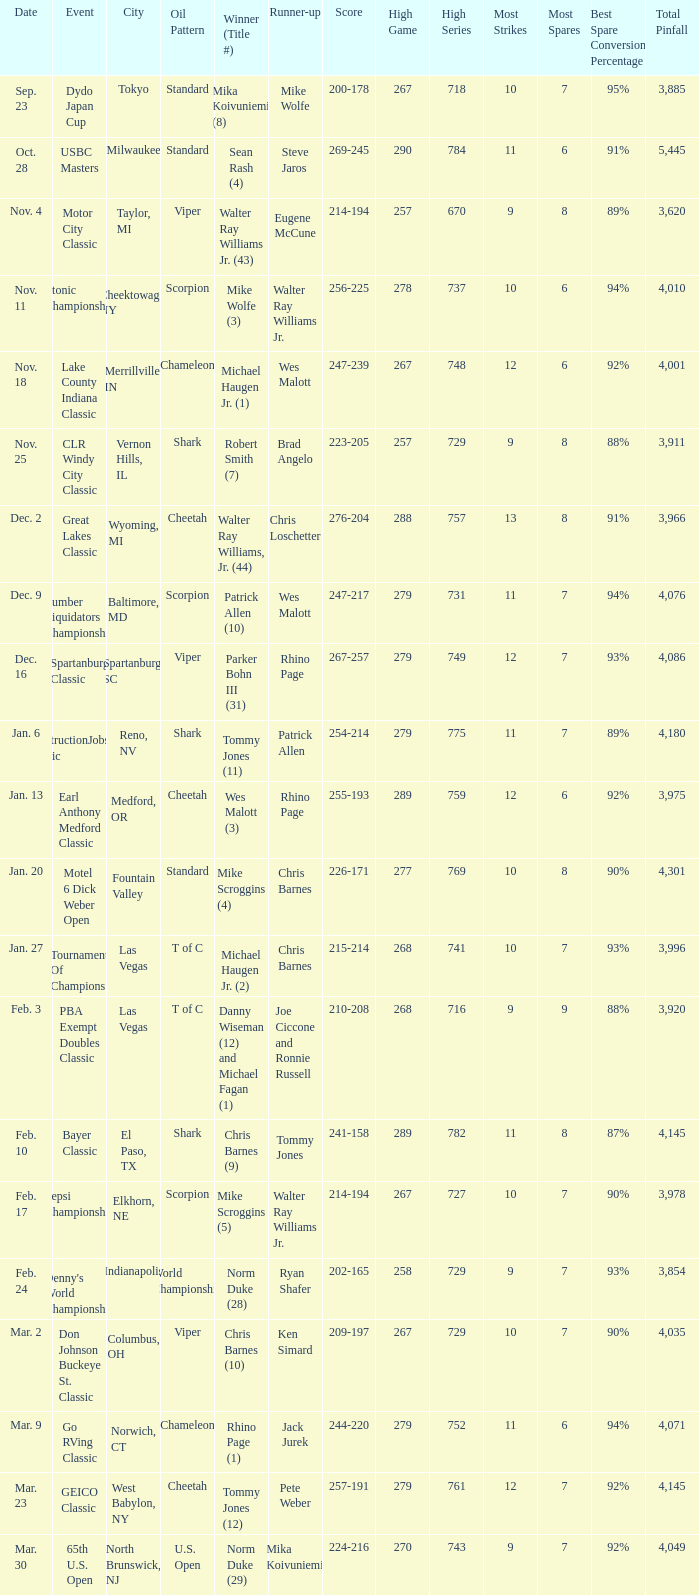Which Oil Pattern has a Winner (Title #) of mike wolfe (3)? Scorpion. 